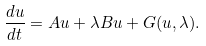Convert formula to latex. <formula><loc_0><loc_0><loc_500><loc_500>\frac { d u } { d t } = A u + \lambda B u + G ( u , \lambda ) .</formula> 